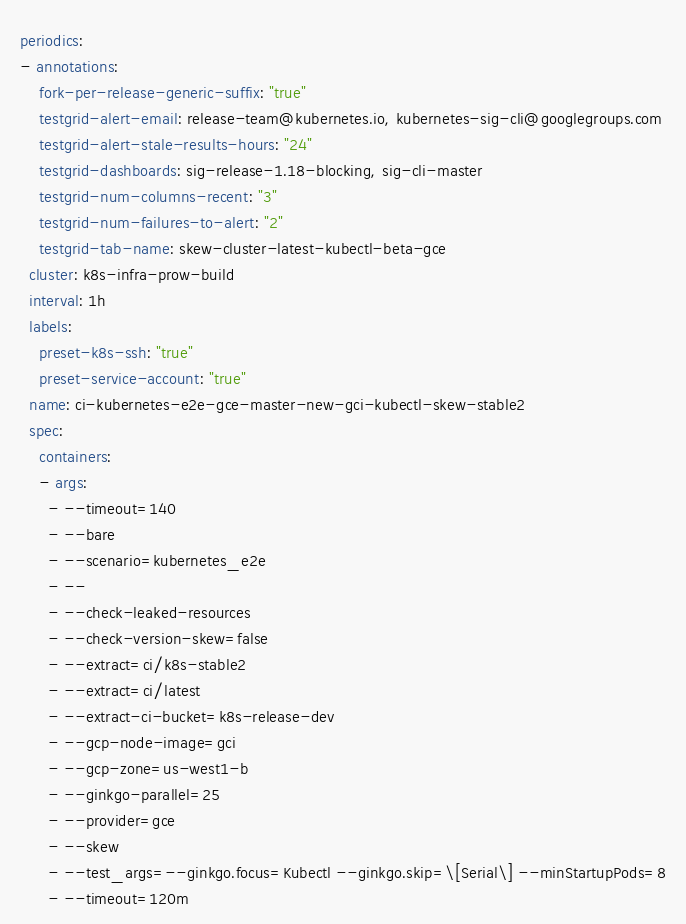<code> <loc_0><loc_0><loc_500><loc_500><_YAML_>periodics:
- annotations:
    fork-per-release-generic-suffix: "true"
    testgrid-alert-email: release-team@kubernetes.io, kubernetes-sig-cli@googlegroups.com
    testgrid-alert-stale-results-hours: "24"
    testgrid-dashboards: sig-release-1.18-blocking, sig-cli-master
    testgrid-num-columns-recent: "3"
    testgrid-num-failures-to-alert: "2"
    testgrid-tab-name: skew-cluster-latest-kubectl-beta-gce
  cluster: k8s-infra-prow-build
  interval: 1h
  labels:
    preset-k8s-ssh: "true"
    preset-service-account: "true"
  name: ci-kubernetes-e2e-gce-master-new-gci-kubectl-skew-stable2
  spec:
    containers:
    - args:
      - --timeout=140
      - --bare
      - --scenario=kubernetes_e2e
      - --
      - --check-leaked-resources
      - --check-version-skew=false
      - --extract=ci/k8s-stable2
      - --extract=ci/latest
      - --extract-ci-bucket=k8s-release-dev
      - --gcp-node-image=gci
      - --gcp-zone=us-west1-b
      - --ginkgo-parallel=25
      - --provider=gce
      - --skew
      - --test_args=--ginkgo.focus=Kubectl --ginkgo.skip=\[Serial\] --minStartupPods=8
      - --timeout=120m</code> 